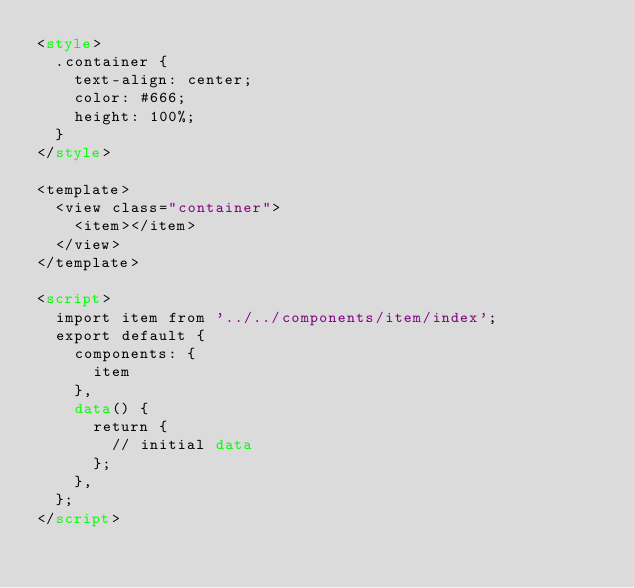Convert code to text. <code><loc_0><loc_0><loc_500><loc_500><_HTML_><style>
  .container {
    text-align: center;
    color: #666;
    height: 100%;
  }
</style>

<template>
  <view class="container">
    <item></item>
  </view>
</template>

<script>
  import item from '../../components/item/index';
  export default {
    components: {
      item
    },
    data() {
      return {
        // initial data
      };
    },
  };
</script>
</code> 